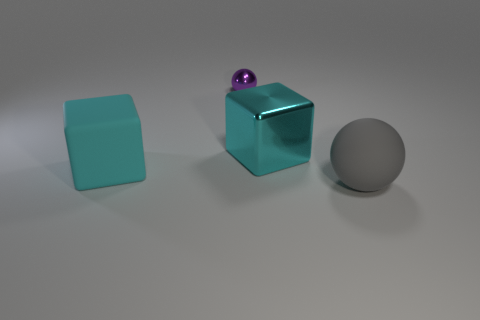Is there anything else that has the same size as the shiny ball?
Make the answer very short. No. Do the big matte thing behind the big gray ball and the large cyan metal object have the same shape?
Offer a very short reply. Yes. Is the tiny purple metal thing the same shape as the big gray object?
Give a very brief answer. Yes. What number of matte objects are blocks or small purple objects?
Make the answer very short. 1. There is a large block that is the same color as the big metal object; what is it made of?
Provide a succinct answer. Rubber. Is the cyan metal thing the same size as the metal ball?
Keep it short and to the point. No. How many things are tiny blue matte objects or spheres in front of the tiny sphere?
Make the answer very short. 1. There is a cyan cube that is the same size as the cyan matte thing; what material is it?
Your answer should be very brief. Metal. The object that is both on the left side of the large cyan metal object and in front of the purple ball is made of what material?
Provide a succinct answer. Rubber. Is there a metal object that is behind the metal thing to the right of the tiny shiny sphere?
Provide a short and direct response. Yes. 